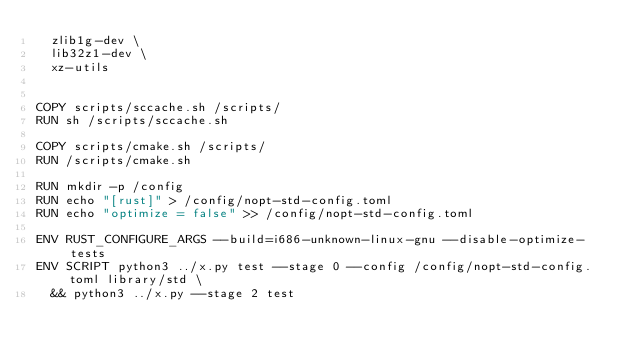Convert code to text. <code><loc_0><loc_0><loc_500><loc_500><_Dockerfile_>  zlib1g-dev \
  lib32z1-dev \
  xz-utils


COPY scripts/sccache.sh /scripts/
RUN sh /scripts/sccache.sh

COPY scripts/cmake.sh /scripts/
RUN /scripts/cmake.sh

RUN mkdir -p /config
RUN echo "[rust]" > /config/nopt-std-config.toml
RUN echo "optimize = false" >> /config/nopt-std-config.toml

ENV RUST_CONFIGURE_ARGS --build=i686-unknown-linux-gnu --disable-optimize-tests
ENV SCRIPT python3 ../x.py test --stage 0 --config /config/nopt-std-config.toml library/std \
  && python3 ../x.py --stage 2 test
</code> 